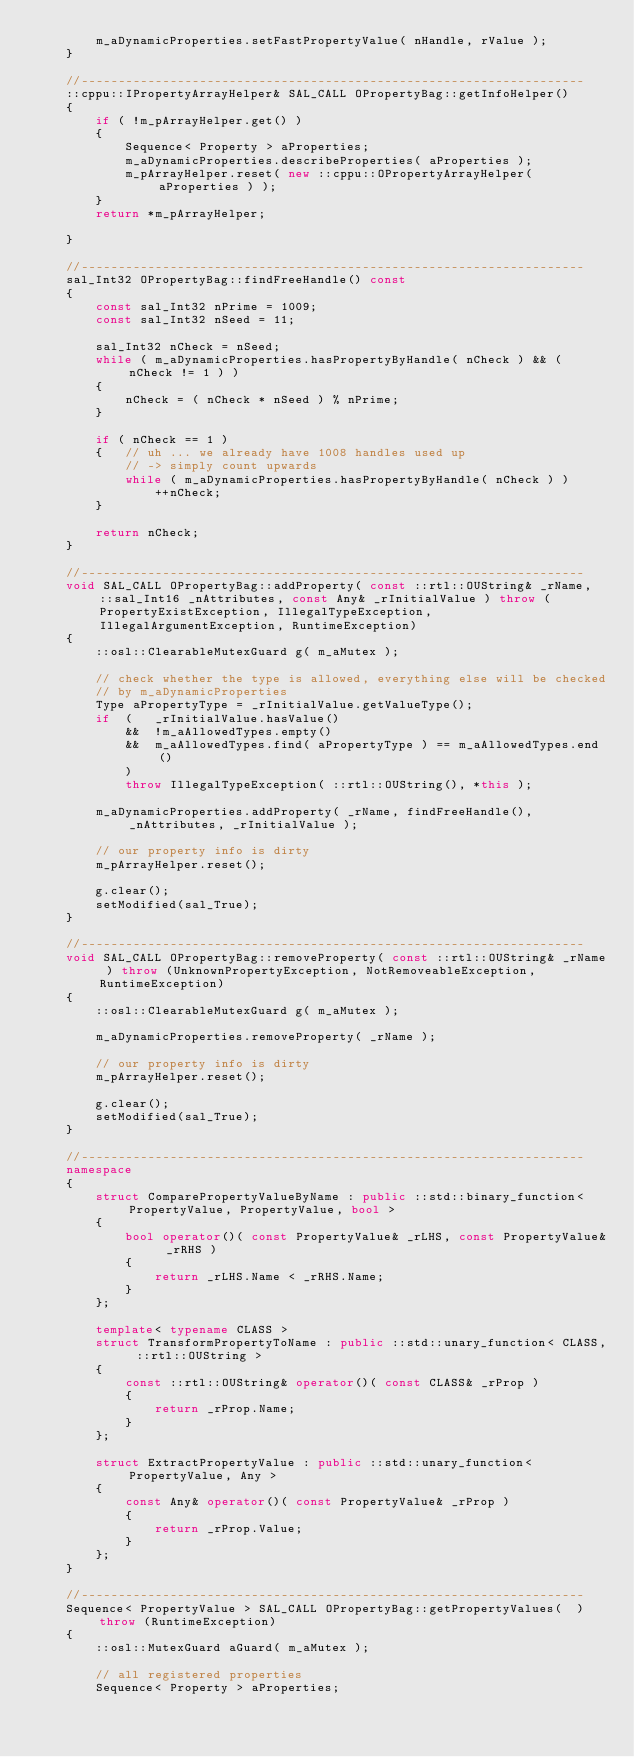<code> <loc_0><loc_0><loc_500><loc_500><_C++_>        m_aDynamicProperties.setFastPropertyValue( nHandle, rValue );
    }

    //--------------------------------------------------------------------
    ::cppu::IPropertyArrayHelper& SAL_CALL OPropertyBag::getInfoHelper()
    {
        if ( !m_pArrayHelper.get() )
        {
            Sequence< Property > aProperties;
            m_aDynamicProperties.describeProperties( aProperties );
            m_pArrayHelper.reset( new ::cppu::OPropertyArrayHelper( aProperties ) );
        }
        return *m_pArrayHelper;

    }

    //--------------------------------------------------------------------
    sal_Int32 OPropertyBag::findFreeHandle() const
    {
        const sal_Int32 nPrime = 1009;
        const sal_Int32 nSeed = 11;

        sal_Int32 nCheck = nSeed;
        while ( m_aDynamicProperties.hasPropertyByHandle( nCheck ) && ( nCheck != 1 ) )
        {
            nCheck = ( nCheck * nSeed ) % nPrime;
        }

        if ( nCheck == 1 )
        {   // uh ... we already have 1008 handles used up
            // -> simply count upwards
            while ( m_aDynamicProperties.hasPropertyByHandle( nCheck ) )
                ++nCheck;
        }

        return nCheck;
    }

    //--------------------------------------------------------------------
    void SAL_CALL OPropertyBag::addProperty( const ::rtl::OUString& _rName, ::sal_Int16 _nAttributes, const Any& _rInitialValue ) throw (PropertyExistException, IllegalTypeException, IllegalArgumentException, RuntimeException)
    {
        ::osl::ClearableMutexGuard g( m_aMutex );

        // check whether the type is allowed, everything else will be checked
        // by m_aDynamicProperties
        Type aPropertyType = _rInitialValue.getValueType();
        if  (   _rInitialValue.hasValue()
            &&  !m_aAllowedTypes.empty()
            &&  m_aAllowedTypes.find( aPropertyType ) == m_aAllowedTypes.end()
            )
            throw IllegalTypeException( ::rtl::OUString(), *this );

        m_aDynamicProperties.addProperty( _rName, findFreeHandle(), _nAttributes, _rInitialValue ); 

        // our property info is dirty
        m_pArrayHelper.reset();

        g.clear();
        setModified(sal_True);
    }

    //--------------------------------------------------------------------
    void SAL_CALL OPropertyBag::removeProperty( const ::rtl::OUString& _rName ) throw (UnknownPropertyException, NotRemoveableException, RuntimeException)
    {
        ::osl::ClearableMutexGuard g( m_aMutex );

        m_aDynamicProperties.removeProperty( _rName );

        // our property info is dirty
        m_pArrayHelper.reset();

        g.clear();
        setModified(sal_True);
    }

    //--------------------------------------------------------------------
    namespace
    {
        struct ComparePropertyValueByName : public ::std::binary_function< PropertyValue, PropertyValue, bool >
        {
            bool operator()( const PropertyValue& _rLHS, const PropertyValue& _rRHS )
            {
                return _rLHS.Name < _rRHS.Name;
            }
        };

        template< typename CLASS >
        struct TransformPropertyToName : public ::std::unary_function< CLASS, ::rtl::OUString >
        {
            const ::rtl::OUString& operator()( const CLASS& _rProp )
            {
                return _rProp.Name;
            }
        };

        struct ExtractPropertyValue : public ::std::unary_function< PropertyValue, Any >
        {
            const Any& operator()( const PropertyValue& _rProp )
            {
                return _rProp.Value;
            }
        };
    }

    //--------------------------------------------------------------------
    Sequence< PropertyValue > SAL_CALL OPropertyBag::getPropertyValues(  ) throw (RuntimeException)
    {
        ::osl::MutexGuard aGuard( m_aMutex );

        // all registered properties
        Sequence< Property > aProperties;</code> 